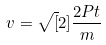<formula> <loc_0><loc_0><loc_500><loc_500>v = \sqrt { [ } 2 ] { \frac { 2 P t } { m } }</formula> 